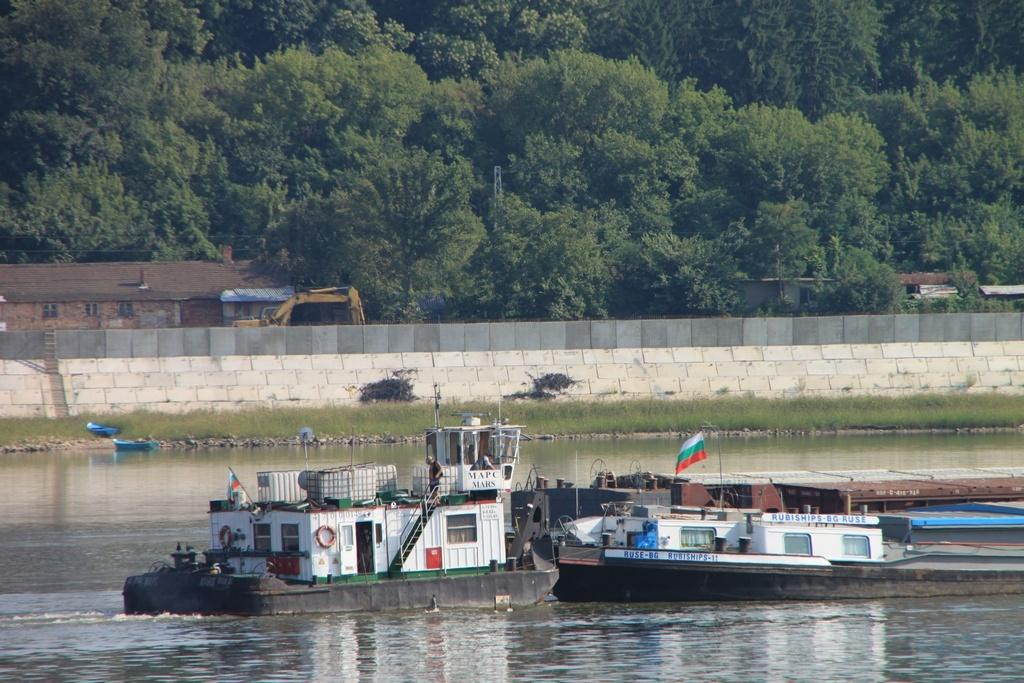What is floating on the water in the image? There are boats floating on the water in the image. What can be seen flying in the image? There is a flag visible in the image. What type of vegetation is present in the image? There is grass in the image. What type of structure is present in the image? There is a stone wall in the image. What type of buildings can be seen in the image? There are houses in the image. What type of construction equipment is present in the image? There is a bulldozer in the image. What can be seen in the background of the image? Trees are present in the background of the image. What type of dog can be seen learning to fetch a ball in the image? There is no dog present in the image, nor is there any indication of learning or fetching a ball. 